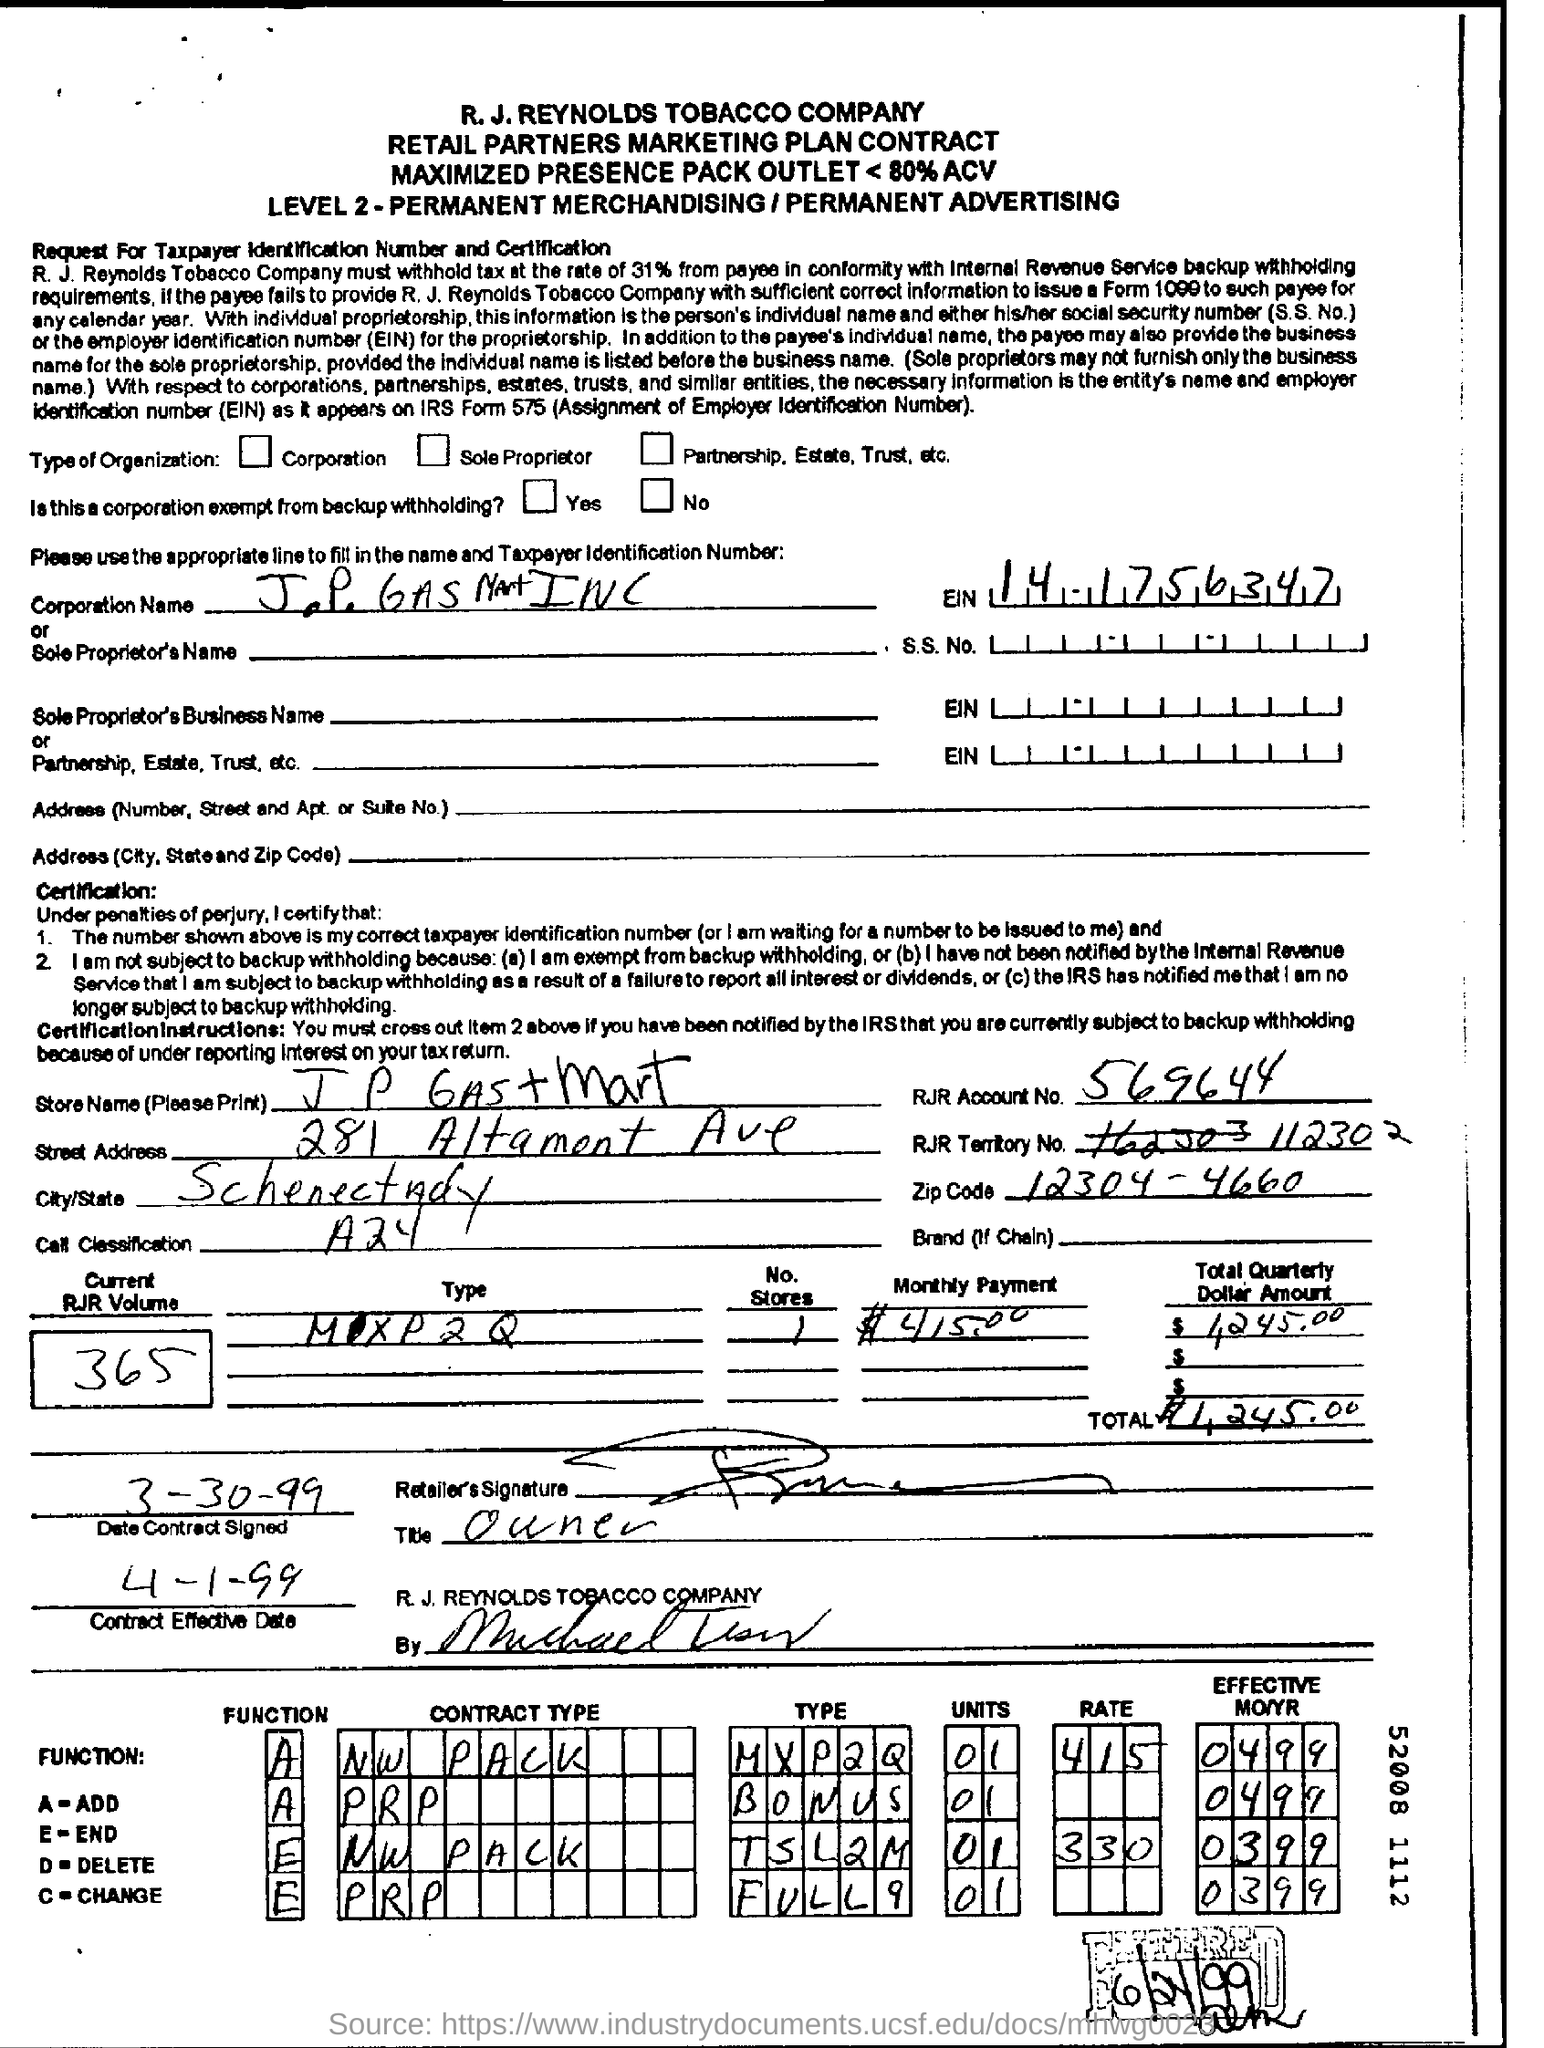List a handful of essential elements in this visual. The EIN is 14.1756347...". The current RJR volume number is 365. The current RJR volume is 365. The monthly payment is $415,000. 